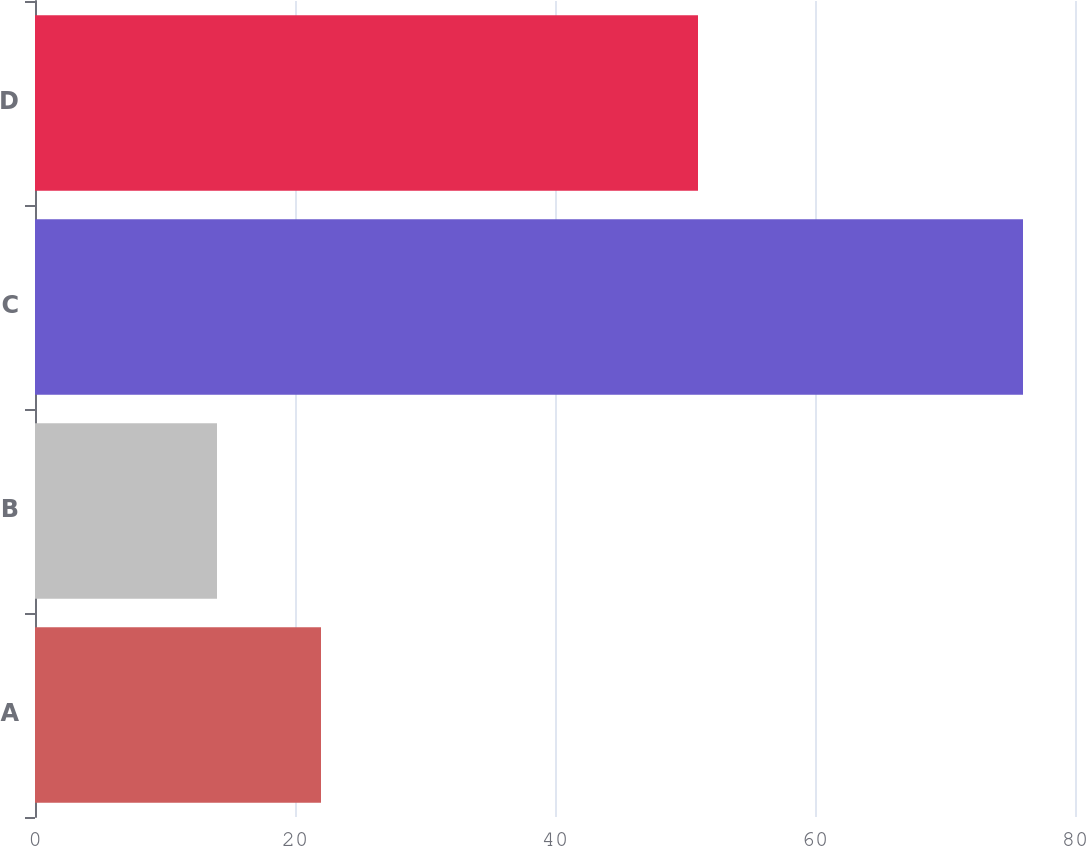<chart> <loc_0><loc_0><loc_500><loc_500><bar_chart><fcel>A<fcel>B<fcel>C<fcel>D<nl><fcel>22<fcel>14<fcel>76<fcel>51<nl></chart> 